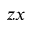Convert formula to latex. <formula><loc_0><loc_0><loc_500><loc_500>z x</formula> 